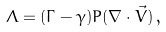<formula> <loc_0><loc_0><loc_500><loc_500>\Lambda = ( \Gamma - \gamma ) P ( \nabla \cdot \vec { V } ) \, ,</formula> 